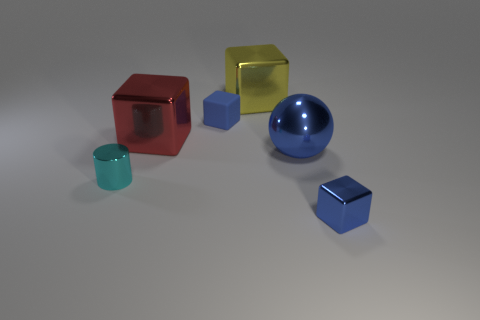Subtract all blue rubber blocks. How many blocks are left? 3 Add 4 big metallic objects. How many objects exist? 10 Subtract 0 green cylinders. How many objects are left? 6 Subtract all balls. How many objects are left? 5 Subtract 3 blocks. How many blocks are left? 1 Subtract all blue cubes. Subtract all purple cylinders. How many cubes are left? 2 Subtract all green cubes. How many yellow cylinders are left? 0 Subtract all small red matte cylinders. Subtract all large things. How many objects are left? 3 Add 2 tiny matte blocks. How many tiny matte blocks are left? 3 Add 5 blue metallic blocks. How many blue metallic blocks exist? 6 